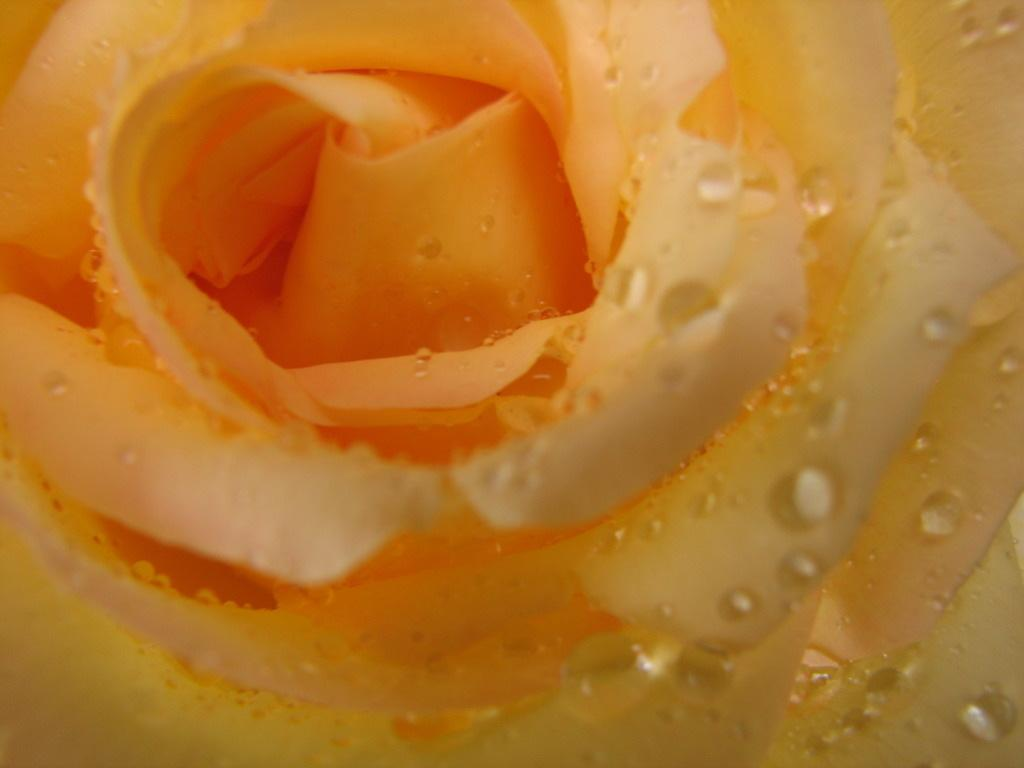What is the main subject of the image? The main subject of the image is a flower. Can you describe the condition of the flower in the image? The flower is truncated in the image. Can you see the hands of the person holding the flower in the image? There is no person holding the flower in the image, and therefore no hands are visible. What phase of the moon is visible in the image? There is no moon visible in the image; it only features a flower. 